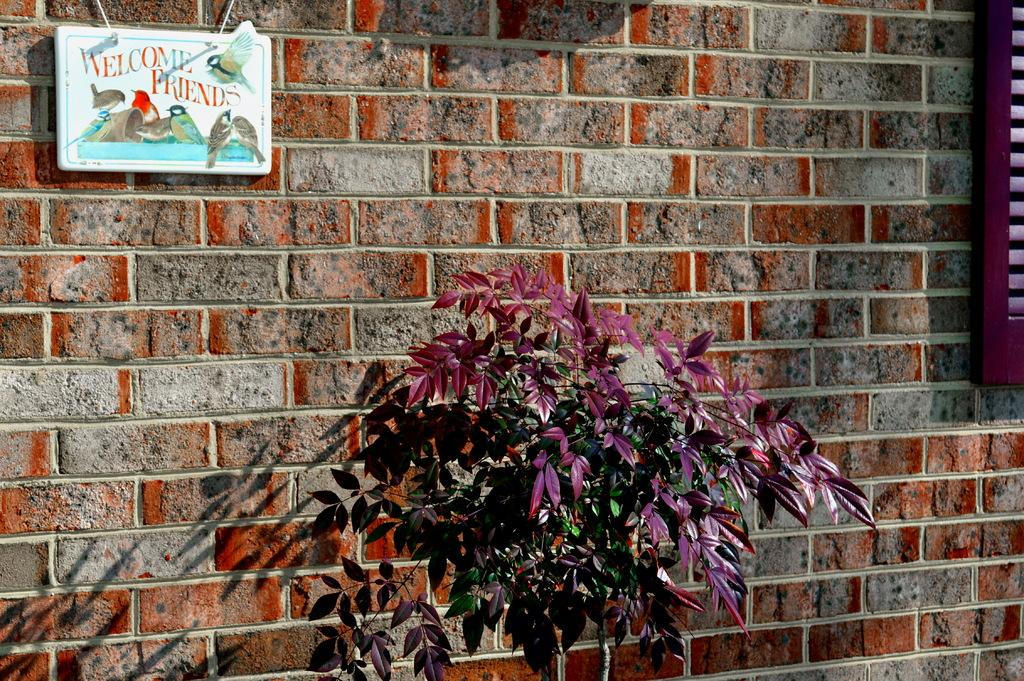What is attached to the wall in the image? There are boards on the wall in the image. What is written or depicted on the boards? There is text on the boards. What can be seen in the foreground of the image? There is a plant in the foreground of the image. What effect does the plant have on the wall in the image? The plant casts a shadow on the wall. What type of coal is being used to fuel the plant in the image? There is no coal or plant being fueled in the image; it features boards on the wall with text and a plant in the foreground that casts a shadow on the wall. How does the daughter interact with the text on the boards in the image? There is no daughter present in the image; it only features boards with text, a plant, and a shadow. 